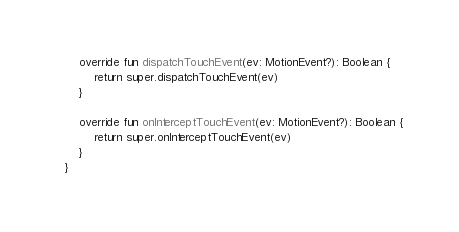<code> <loc_0><loc_0><loc_500><loc_500><_Kotlin_>    override fun dispatchTouchEvent(ev: MotionEvent?): Boolean {
        return super.dispatchTouchEvent(ev)
    }

    override fun onInterceptTouchEvent(ev: MotionEvent?): Boolean {
        return super.onInterceptTouchEvent(ev)
    }
}</code> 